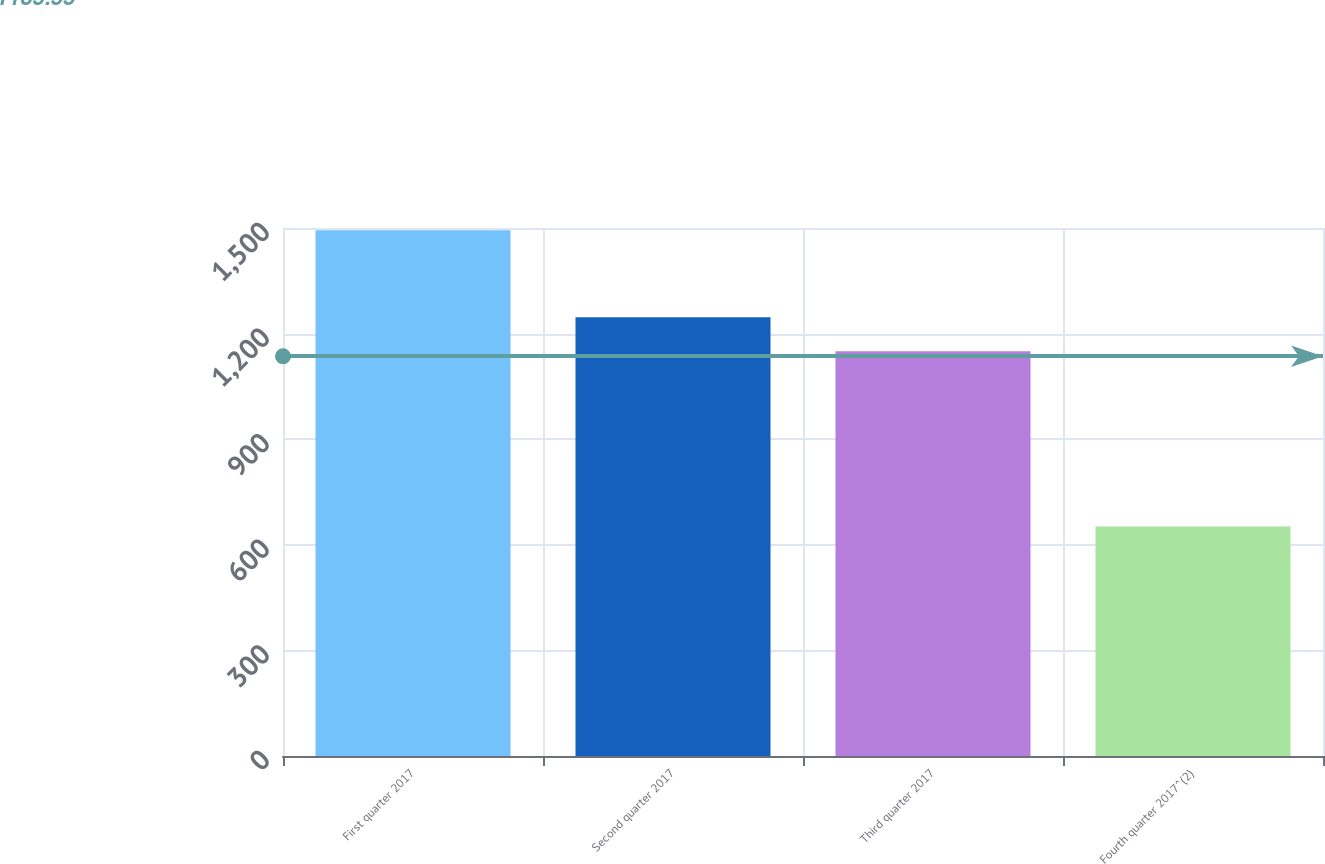Convert chart. <chart><loc_0><loc_0><loc_500><loc_500><bar_chart><fcel>First quarter 2017<fcel>Second quarter 2017<fcel>Third quarter 2017<fcel>Fourth quarter 2017^(2)<nl><fcel>1493.4<fcel>1246.8<fcel>1150<fcel>652<nl></chart> 